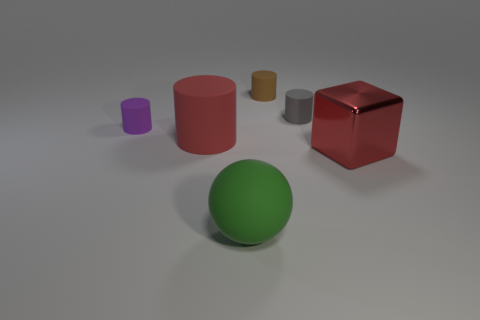How could a teacher use these objects in a mathematics lesson? A teacher might use these objects to teach about geometry, allowing students to explore the properties of different shapes like cylinders, cubes, and spheres. They could also be used for counting exercises or to explain concepts like volume and surface area by comparing the objects. 